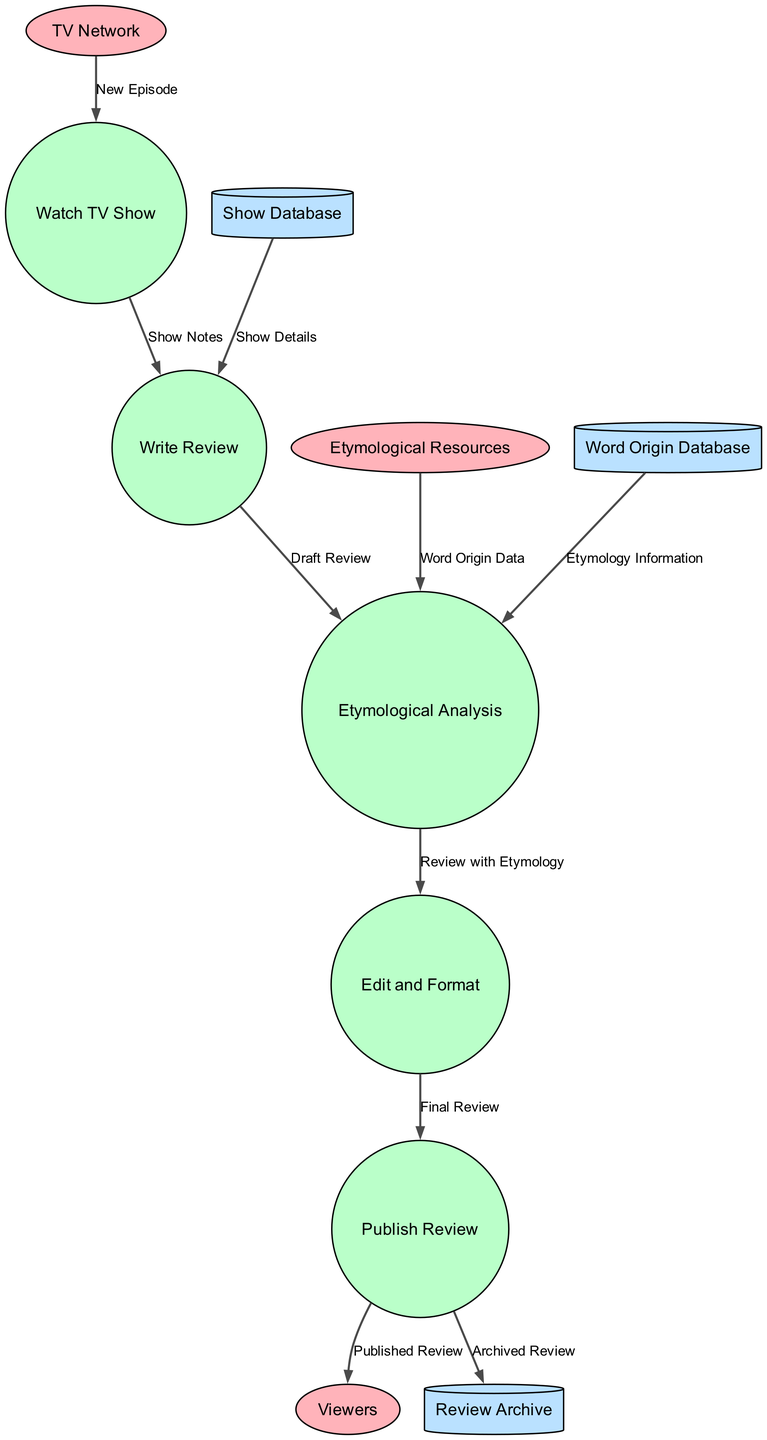What is the first process in the flow? The first process in the diagram is connected directly from the external entity "TV Network" and is labeled as "Watch TV Show".
Answer: Watch TV Show How many data stores are depicted in the diagram? There are three data stores shown in the diagram: "Show Database", "Review Archive", and "Word Origin Database". Counting these gives a total of three.
Answer: 3 Which external entity provides "Word Origin Data"? The external entity providing "Word Origin Data" is "Etymological Resources", as indicated by the flow directed towards "Etymological Analysis".
Answer: Etymological Resources What is the label on the flow from "Write Review" to "Etymological Analysis"? The flow from "Write Review" to "Etymological Analysis" is labeled "Draft Review", as visible in the diagram connecting these two nodes.
Answer: Draft Review Which process receives "Show Details" as input? "Write Review" receives "Show Details" as input, as shown from the data flow originating from the "Show Database".
Answer: Write Review Which process is the final step before a review is shared with viewers? The final step before a review reaches viewers is the "Publish Review" process, which is the last process in the diagram before the output flows to "Viewers".
Answer: Publish Review How many edges are connected to "Etymological Analysis"? The "Etymological Analysis" node has two incoming edges: one from "Write Review" and another from "Etymological Resources", making it a total of two edges.
Answer: 2 What is archived after publishing a review? After publishing a review, it is archived in the "Review Archive" as shown by the flow directed from "Publish Review" to "Review Archive".
Answer: Archived Review Which process directly uses the "Etymology Information"? The "Etymological Analysis" process directly uses "Etymology Information", as indicated by the flow leading into it from the "Word Origin Database".
Answer: Etymological Analysis 